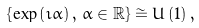<formula> <loc_0><loc_0><loc_500><loc_500>\left \{ \exp \left ( \imath \alpha \right ) , \, \alpha \in \mathbb { R } \right \} & \cong U \left ( 1 \right ) ,</formula> 